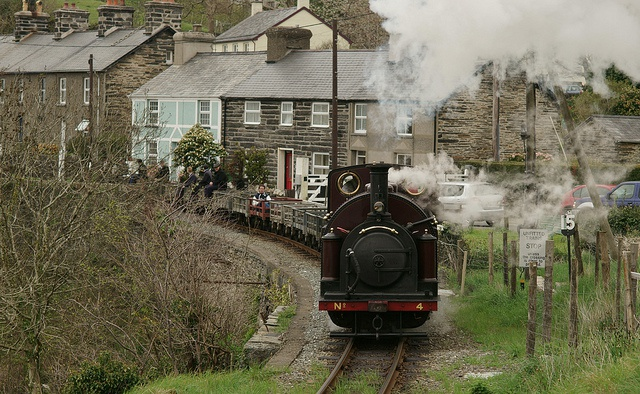Describe the objects in this image and their specific colors. I can see train in darkgreen, black, gray, and maroon tones, car in darkgreen, darkgray, lightgray, and gray tones, car in darkgreen, gray, and darkgray tones, car in darkgreen, darkgray, gray, and lightpink tones, and people in darkgreen, black, gray, and maroon tones in this image. 